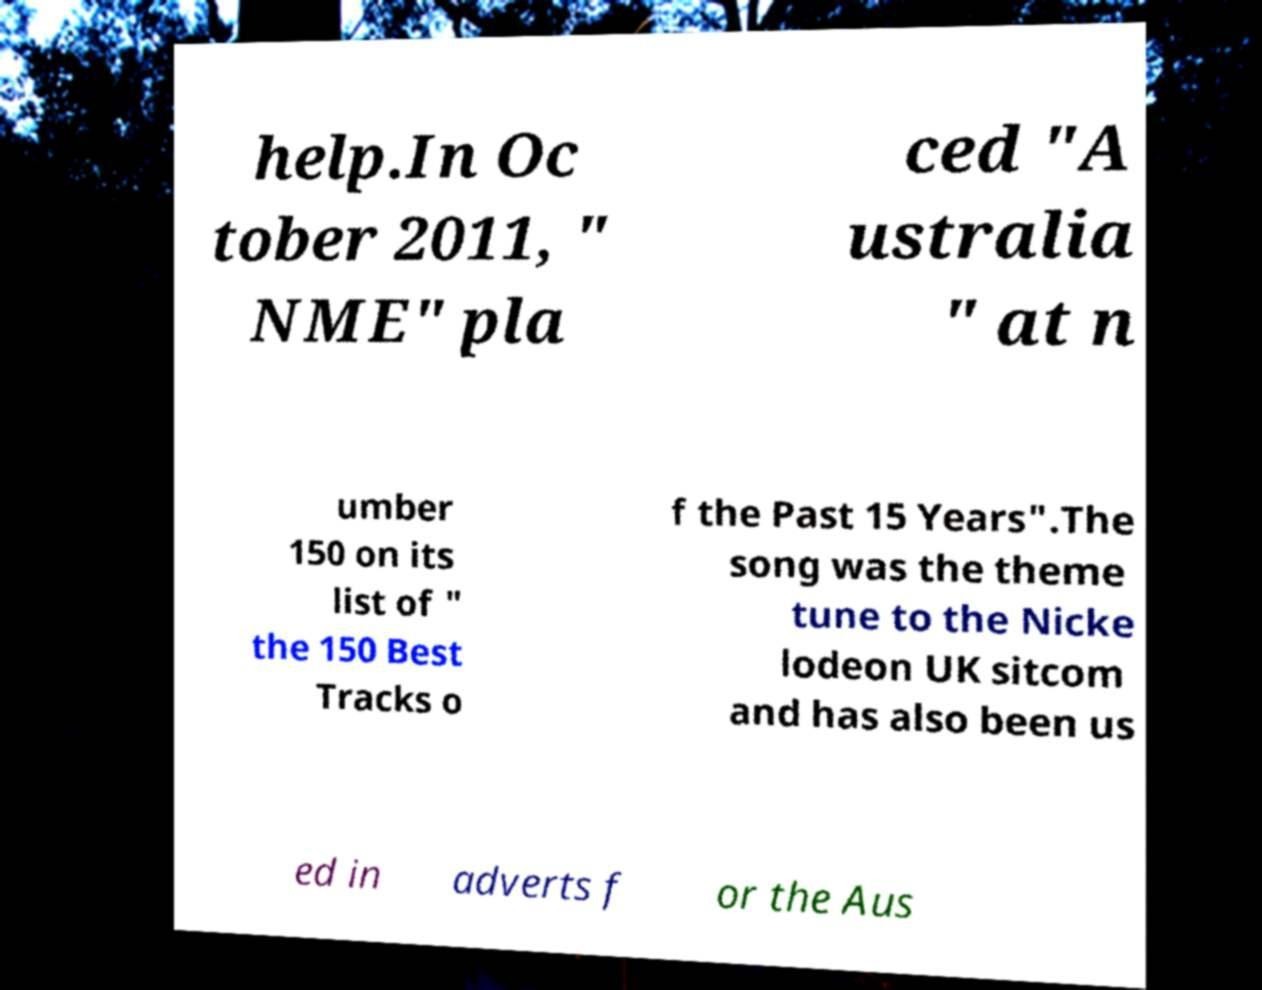Please read and relay the text visible in this image. What does it say? help.In Oc tober 2011, " NME" pla ced "A ustralia " at n umber 150 on its list of " the 150 Best Tracks o f the Past 15 Years".The song was the theme tune to the Nicke lodeon UK sitcom and has also been us ed in adverts f or the Aus 